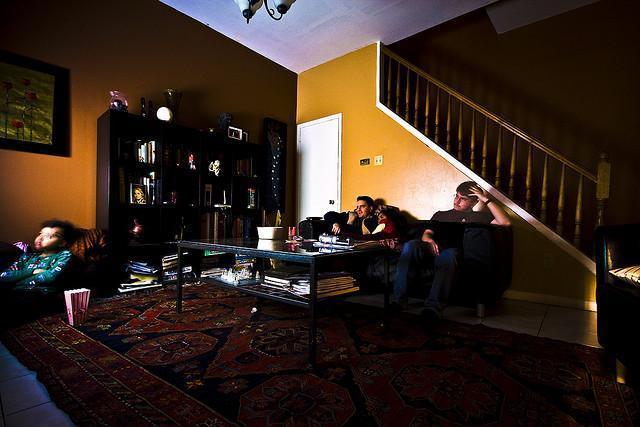How many people are in the picture?
Give a very brief answer. 2. How many chairs can you see?
Give a very brief answer. 2. How many drinks cups have straw?
Give a very brief answer. 0. 